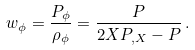<formula> <loc_0><loc_0><loc_500><loc_500>w _ { \phi } = \frac { P _ { \phi } } { \rho _ { \phi } } = \frac { P } { 2 X P _ { , X } - P } \, .</formula> 